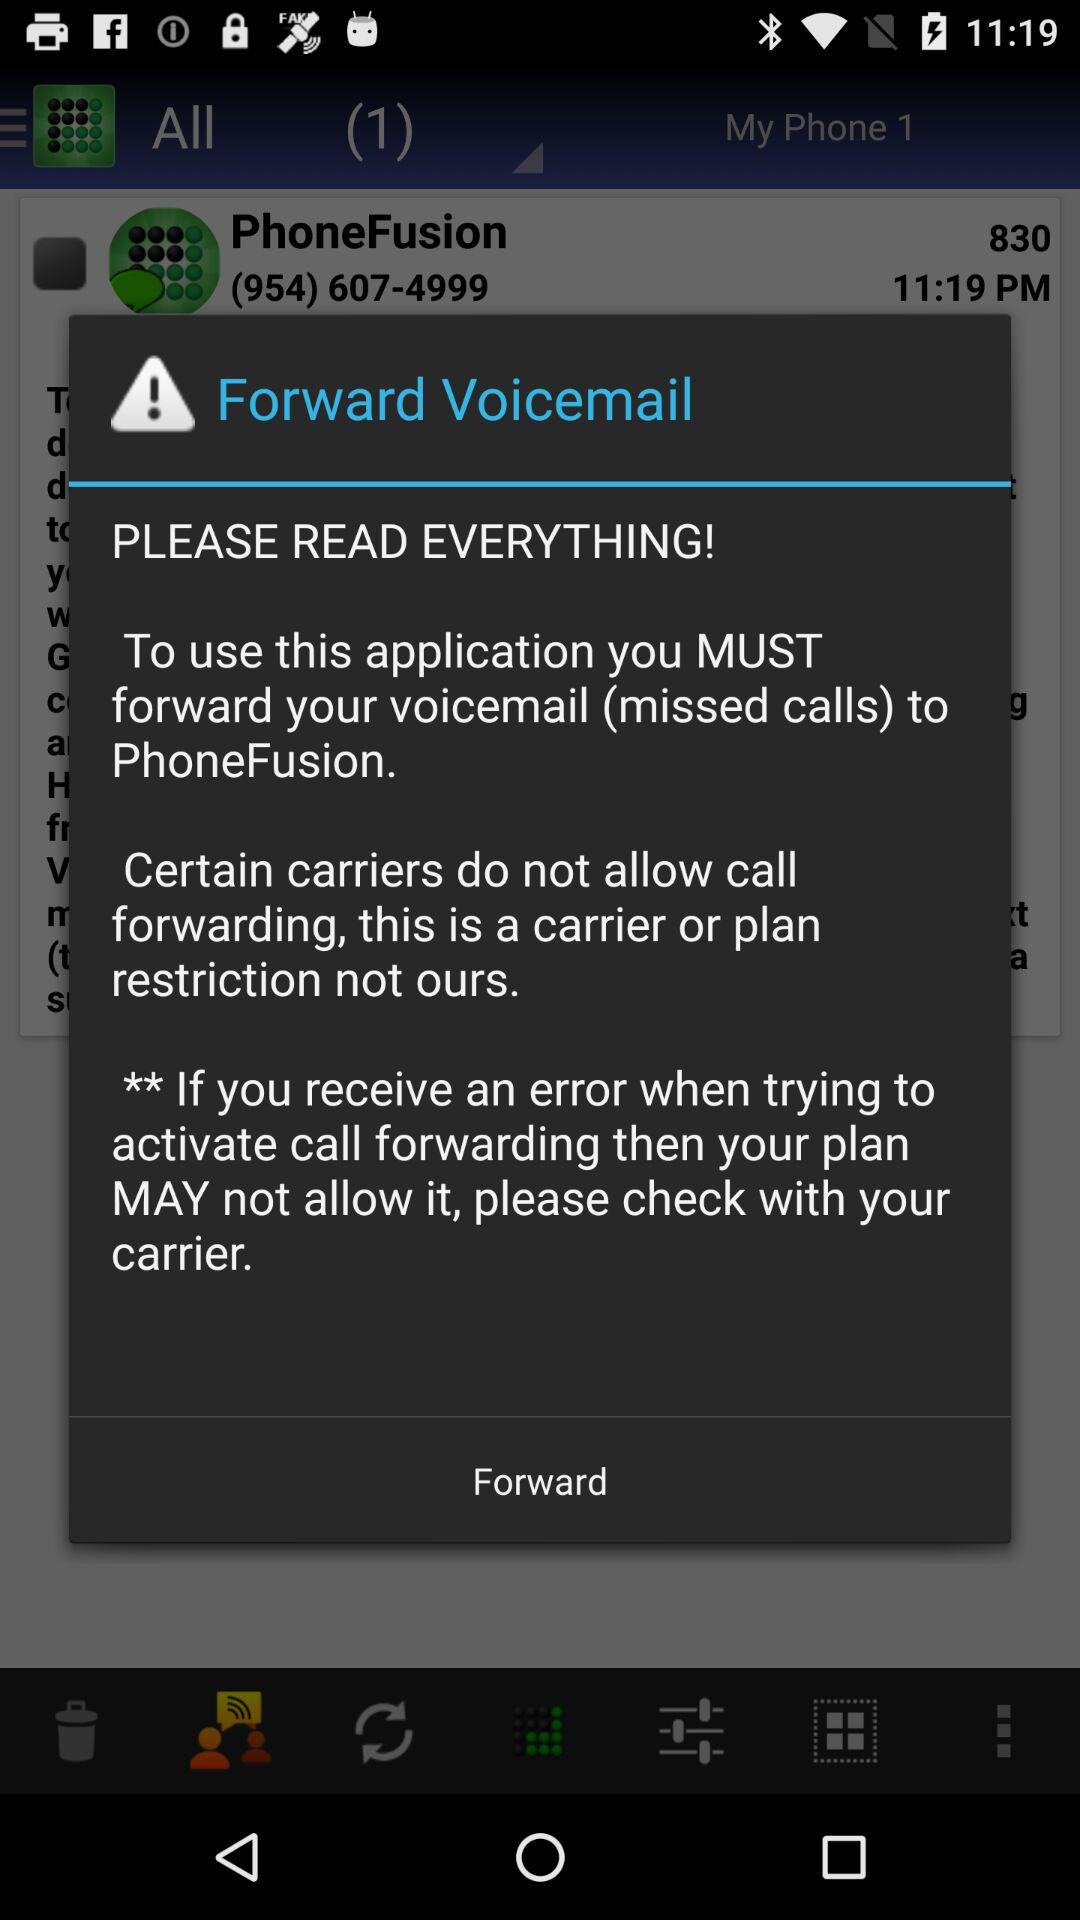Where should the voicemail be forwarded? The voicemail should be forwarded to "PhoneFusion". 